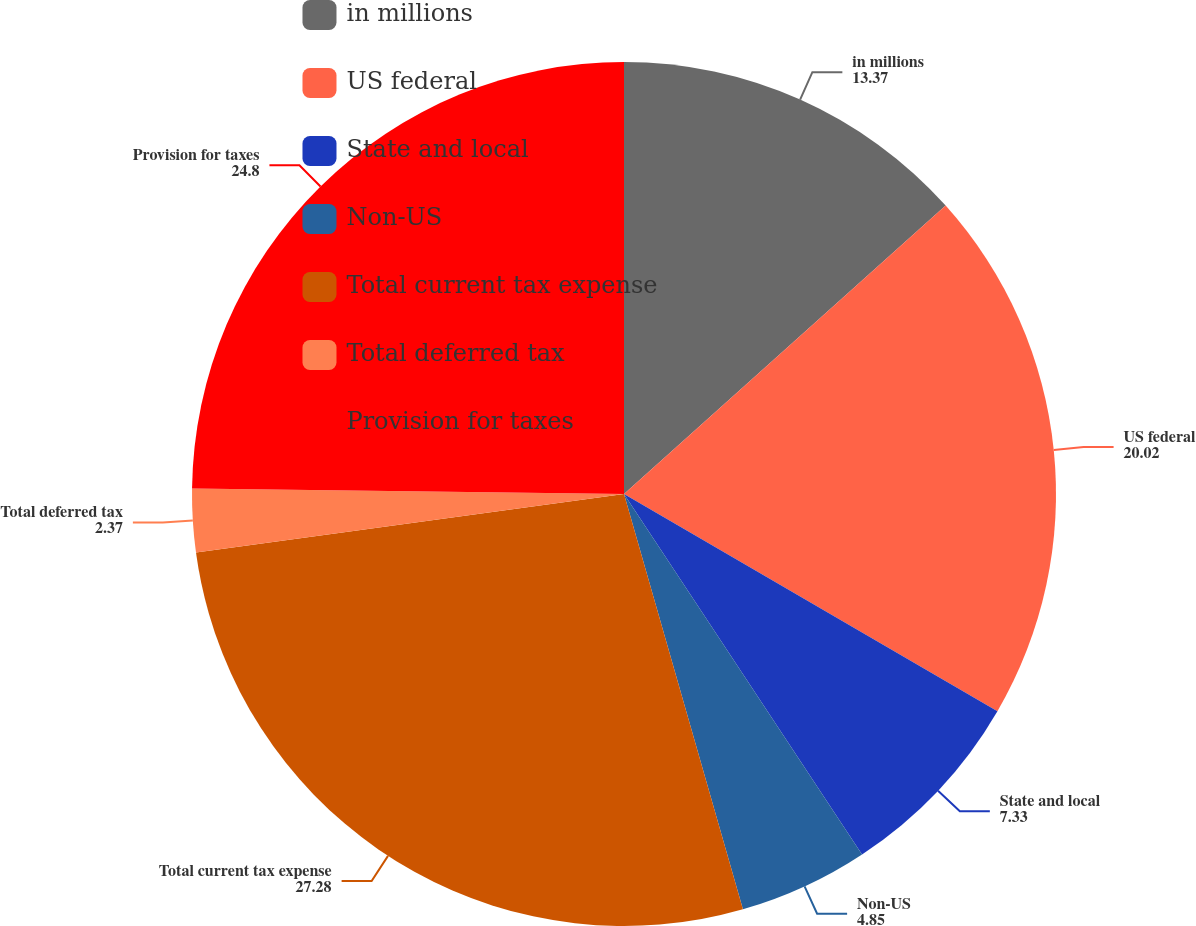Convert chart. <chart><loc_0><loc_0><loc_500><loc_500><pie_chart><fcel>in millions<fcel>US federal<fcel>State and local<fcel>Non-US<fcel>Total current tax expense<fcel>Total deferred tax<fcel>Provision for taxes<nl><fcel>13.37%<fcel>20.02%<fcel>7.33%<fcel>4.85%<fcel>27.28%<fcel>2.37%<fcel>24.8%<nl></chart> 